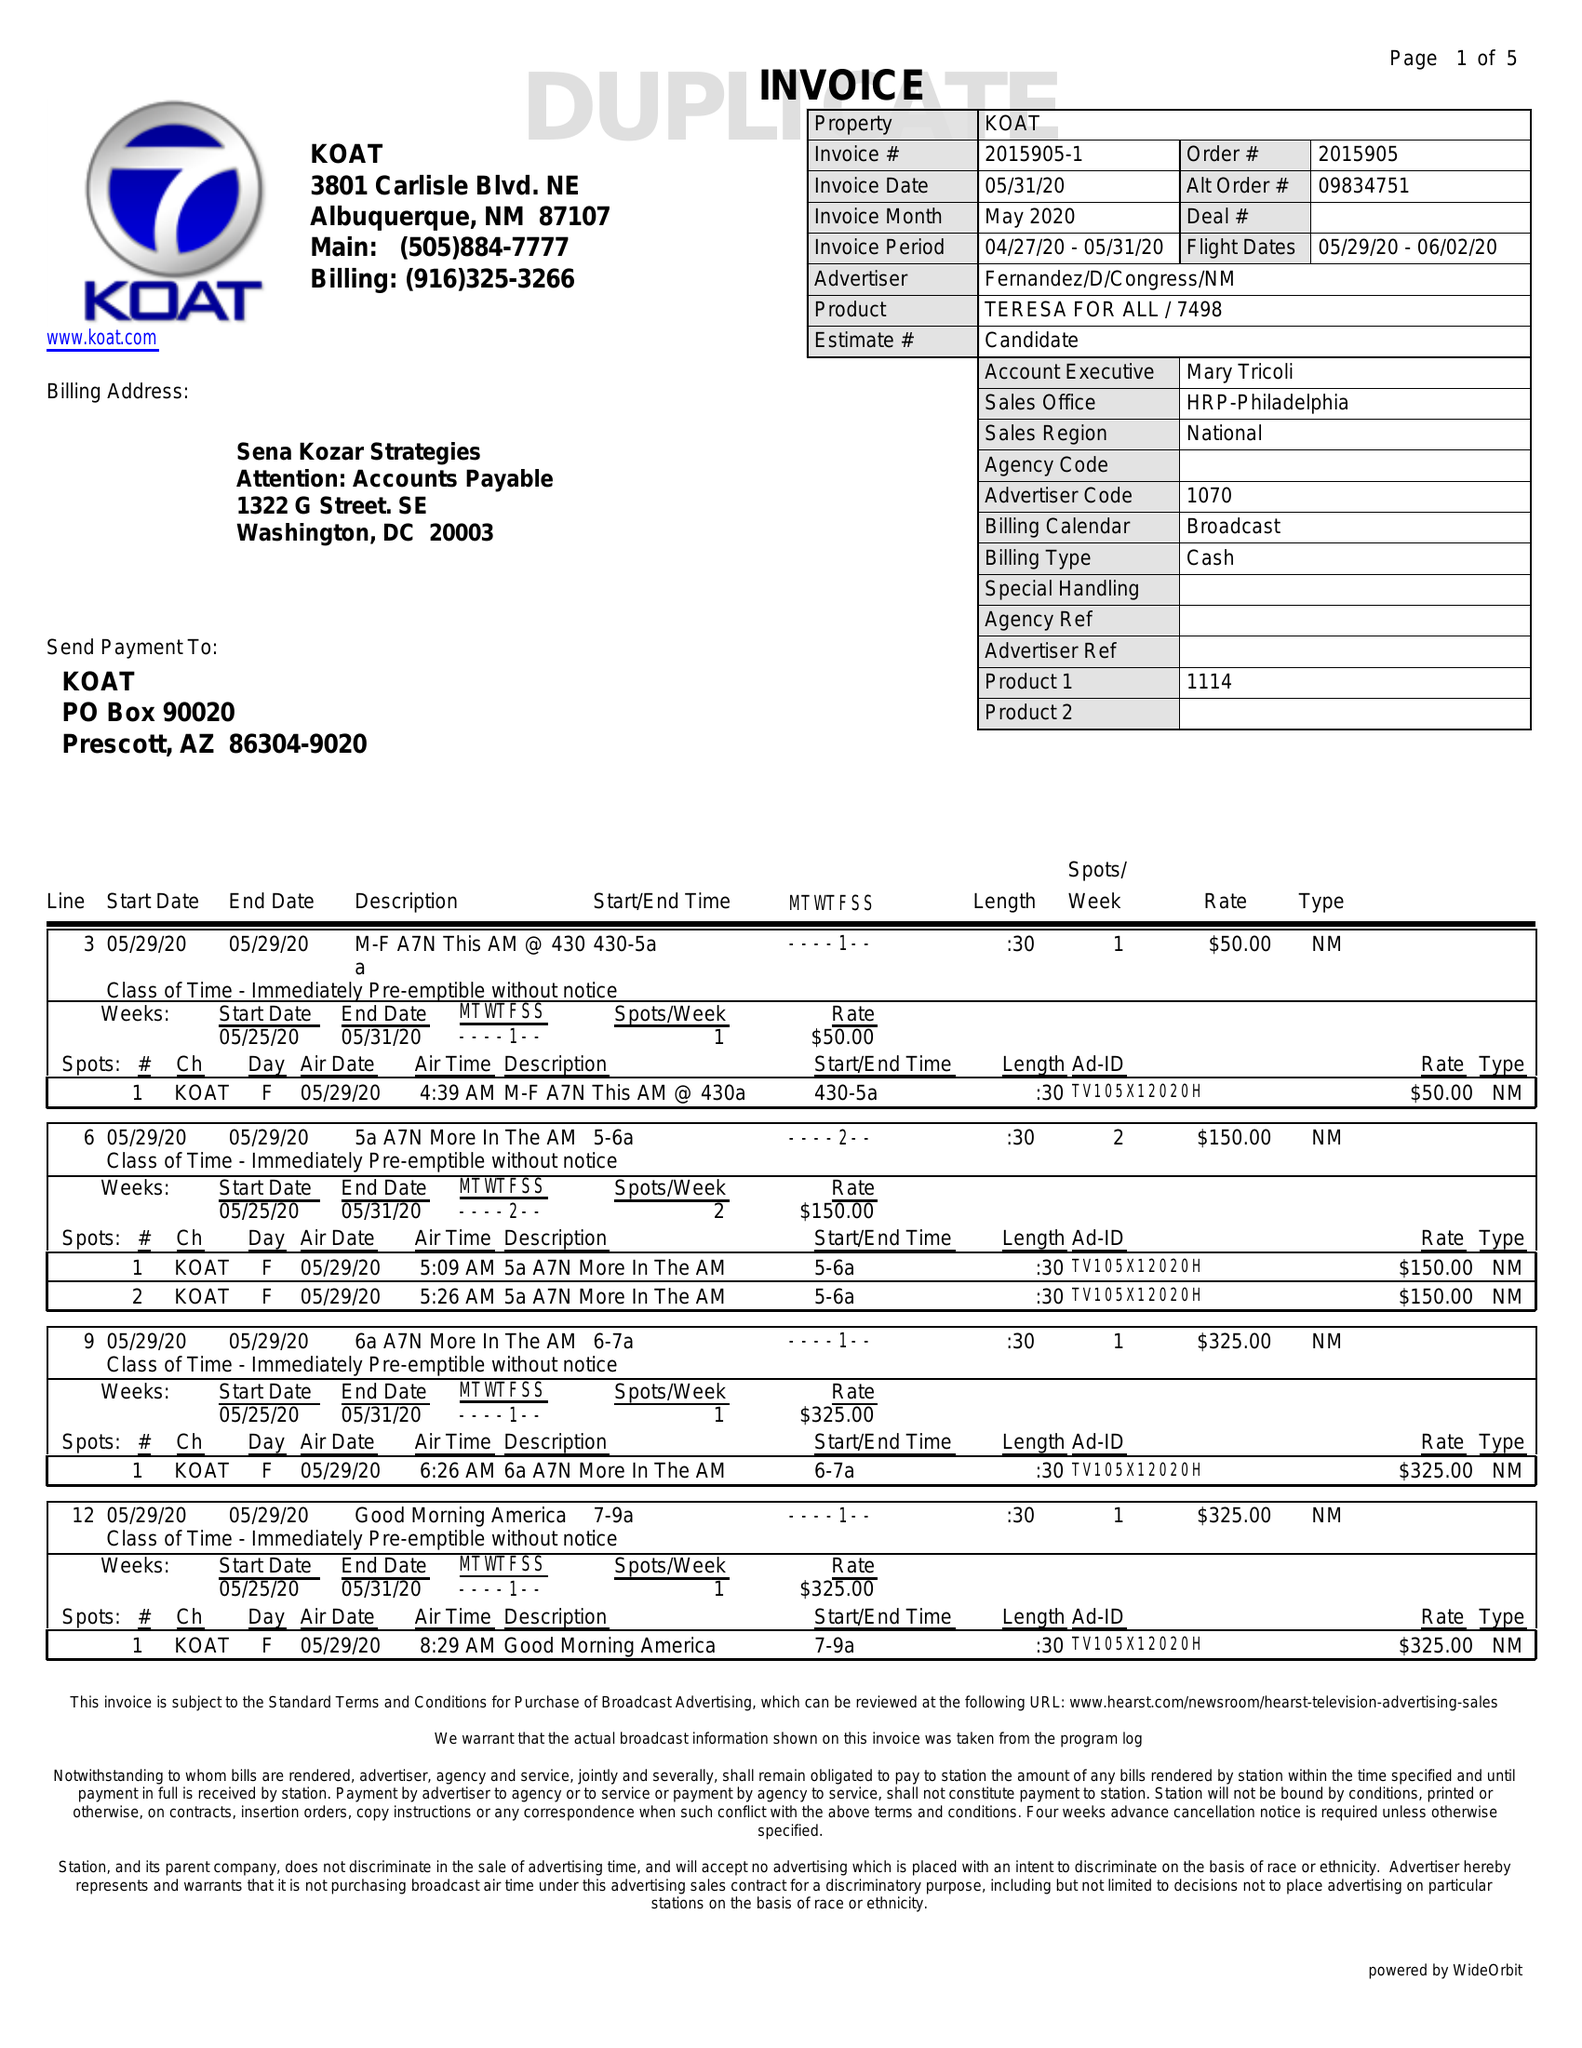What is the value for the flight_from?
Answer the question using a single word or phrase. 05/29/20 